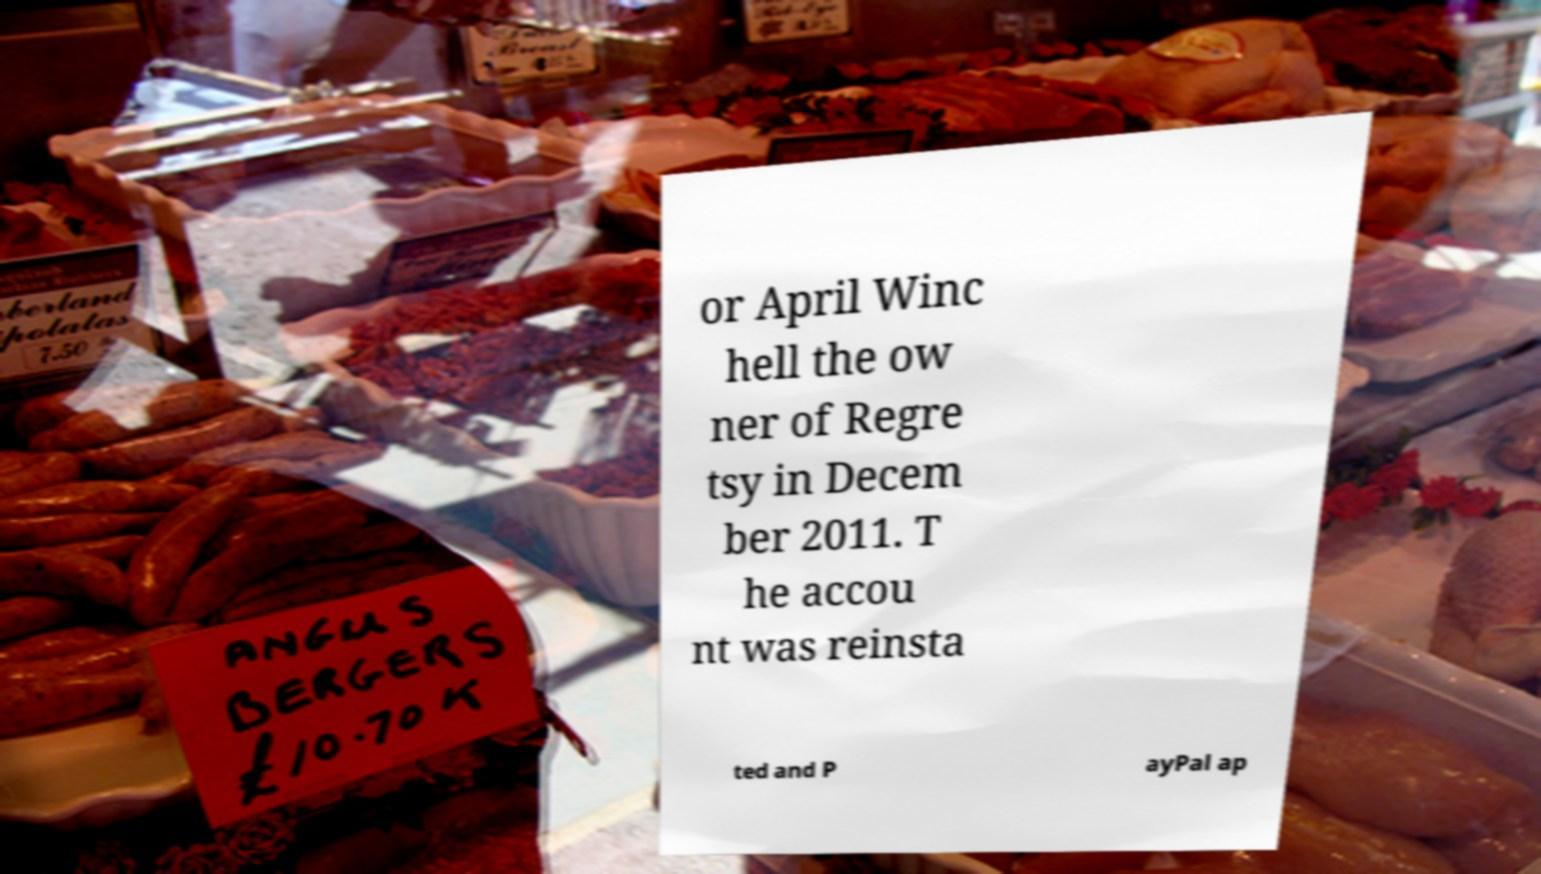Could you assist in decoding the text presented in this image and type it out clearly? or April Winc hell the ow ner of Regre tsy in Decem ber 2011. T he accou nt was reinsta ted and P ayPal ap 